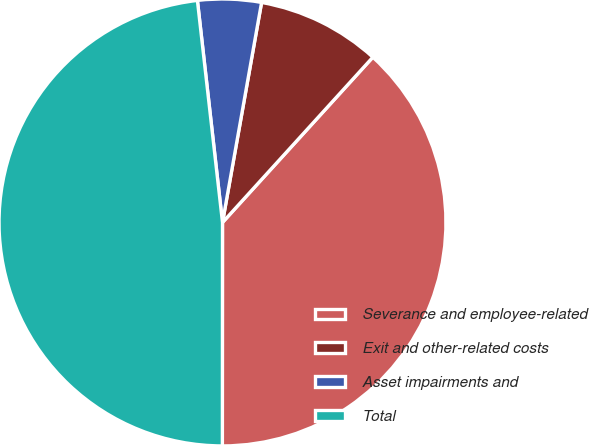<chart> <loc_0><loc_0><loc_500><loc_500><pie_chart><fcel>Severance and employee-related<fcel>Exit and other-related costs<fcel>Asset impairments and<fcel>Total<nl><fcel>38.26%<fcel>8.95%<fcel>4.59%<fcel>48.2%<nl></chart> 